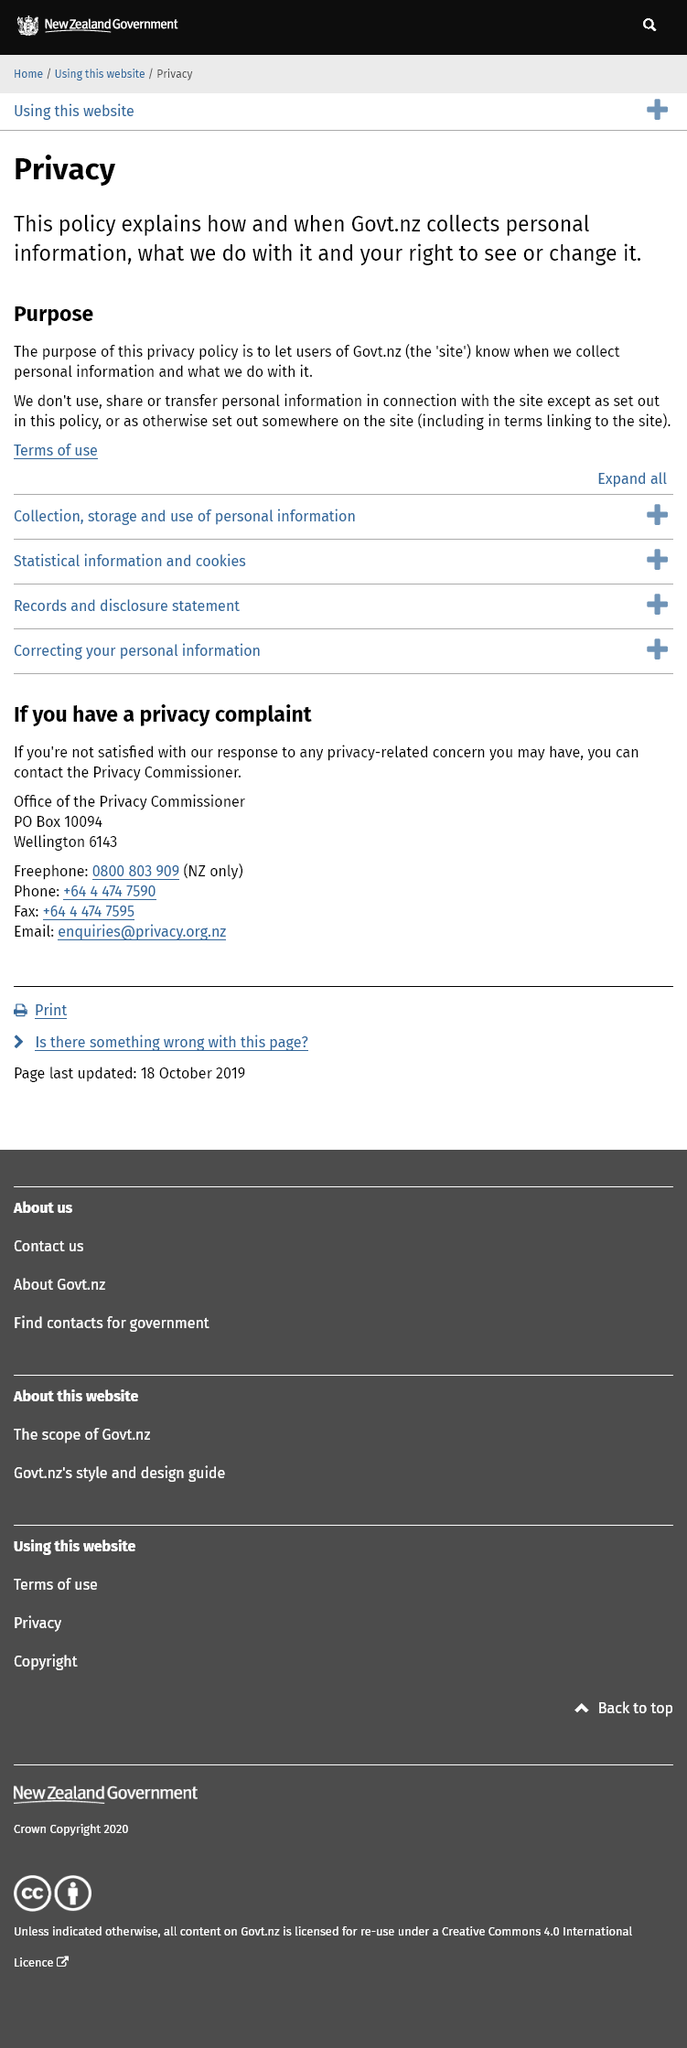Mention a couple of crucial points in this snapshot. Govt.nz does not share personal information without disclosing it to the user and does not use, share, or transfer personal information except as set out in policy or on the website. Govt.nz collects and uses your information as described in this policy. The privacy policy of Govt.nz is intended to inform users about the collection and use of their personal information. 